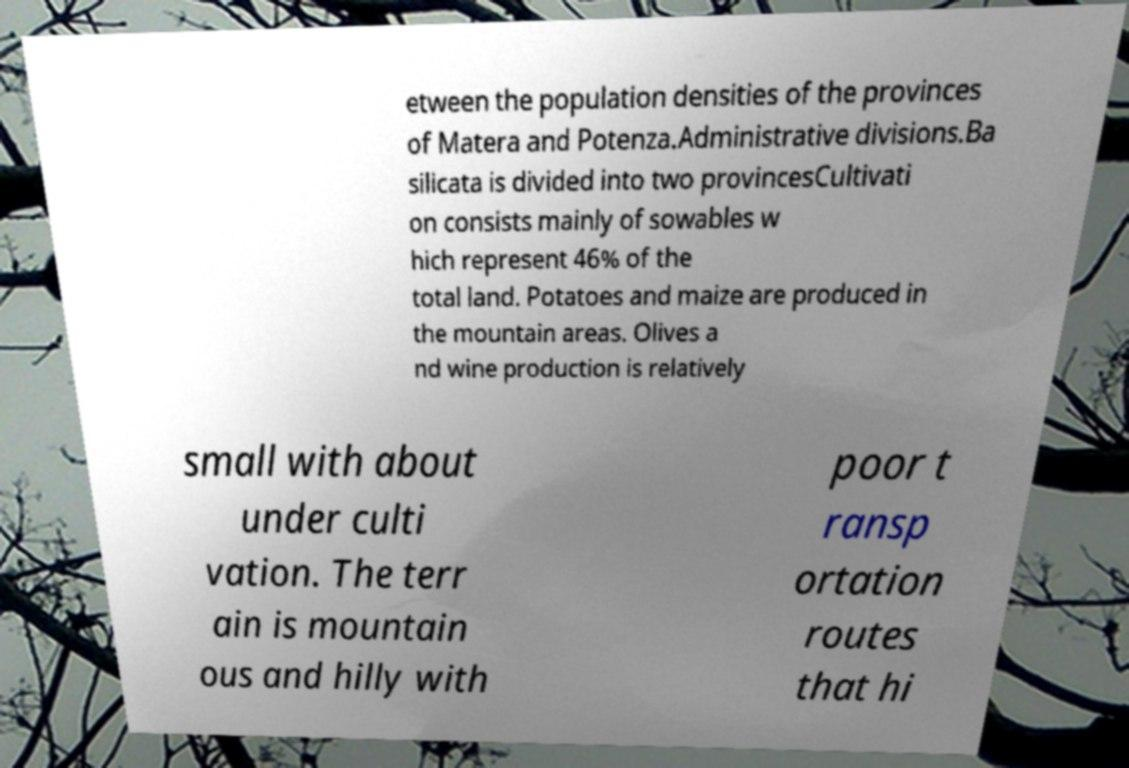There's text embedded in this image that I need extracted. Can you transcribe it verbatim? etween the population densities of the provinces of Matera and Potenza.Administrative divisions.Ba silicata is divided into two provincesCultivati on consists mainly of sowables w hich represent 46% of the total land. Potatoes and maize are produced in the mountain areas. Olives a nd wine production is relatively small with about under culti vation. The terr ain is mountain ous and hilly with poor t ransp ortation routes that hi 